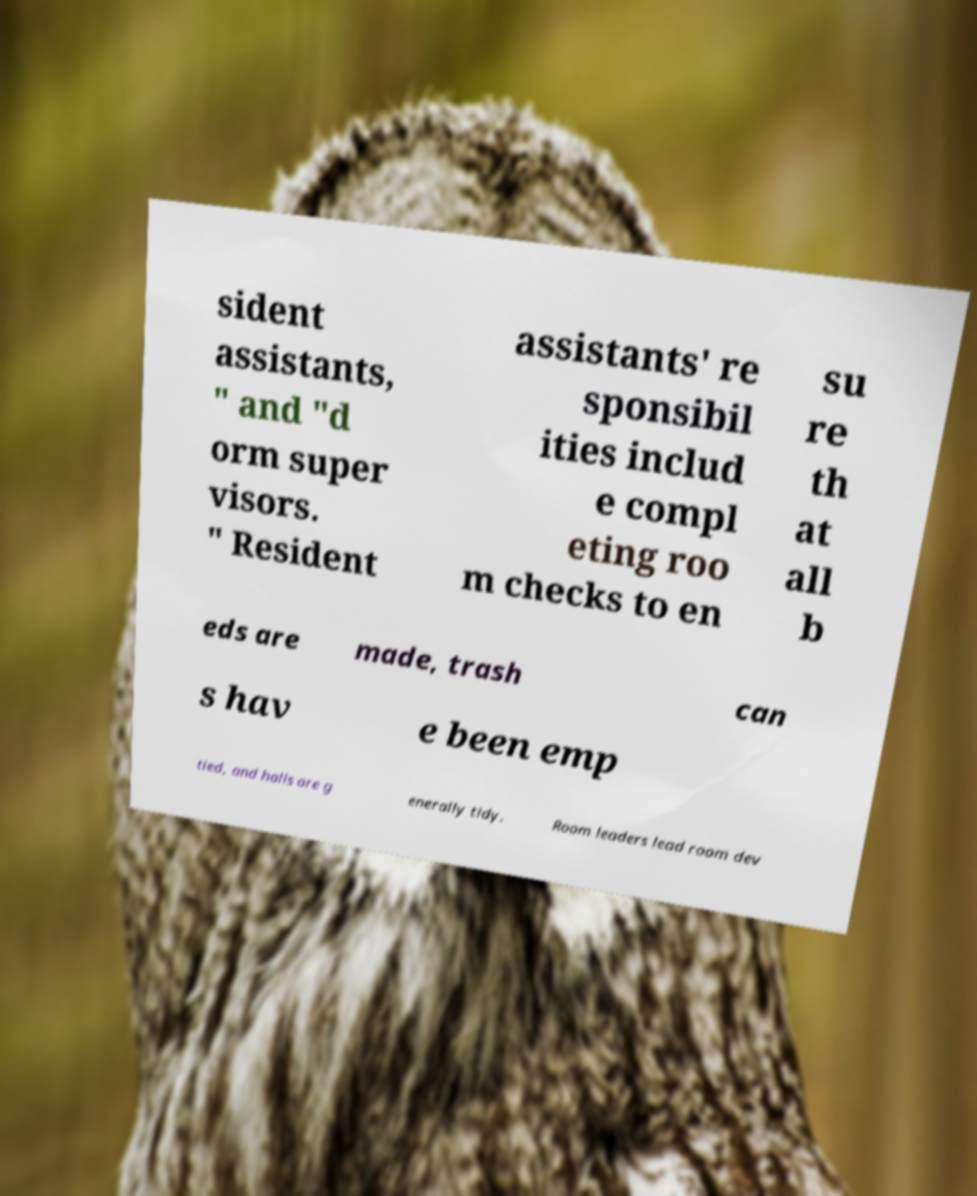Could you assist in decoding the text presented in this image and type it out clearly? sident assistants, " and "d orm super visors. " Resident assistants' re sponsibil ities includ e compl eting roo m checks to en su re th at all b eds are made, trash can s hav e been emp tied, and halls are g enerally tidy. Room leaders lead room dev 